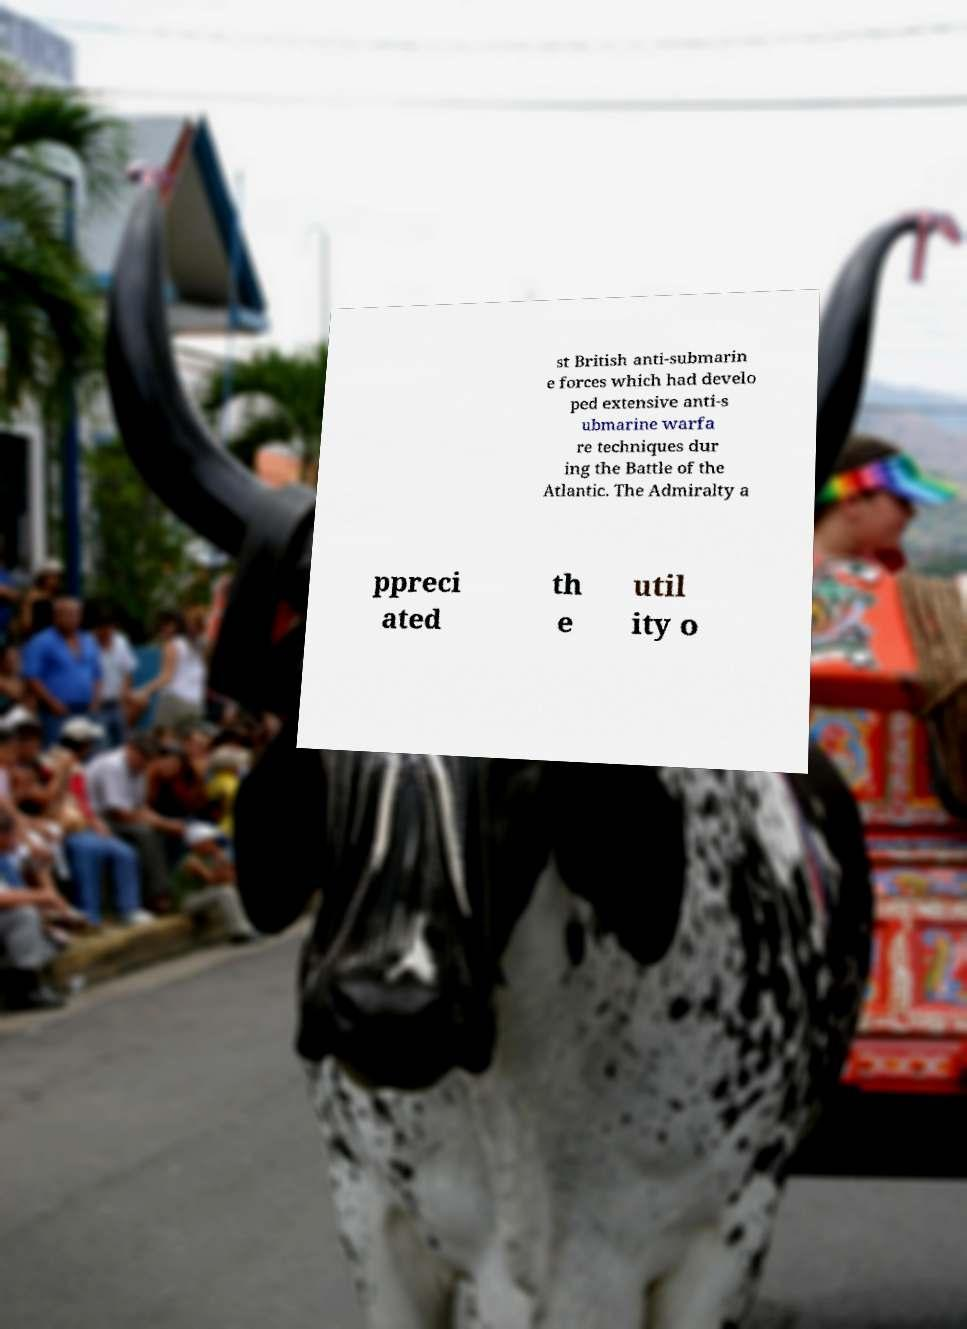Could you assist in decoding the text presented in this image and type it out clearly? st British anti-submarin e forces which had develo ped extensive anti-s ubmarine warfa re techniques dur ing the Battle of the Atlantic. The Admiralty a ppreci ated th e util ity o 